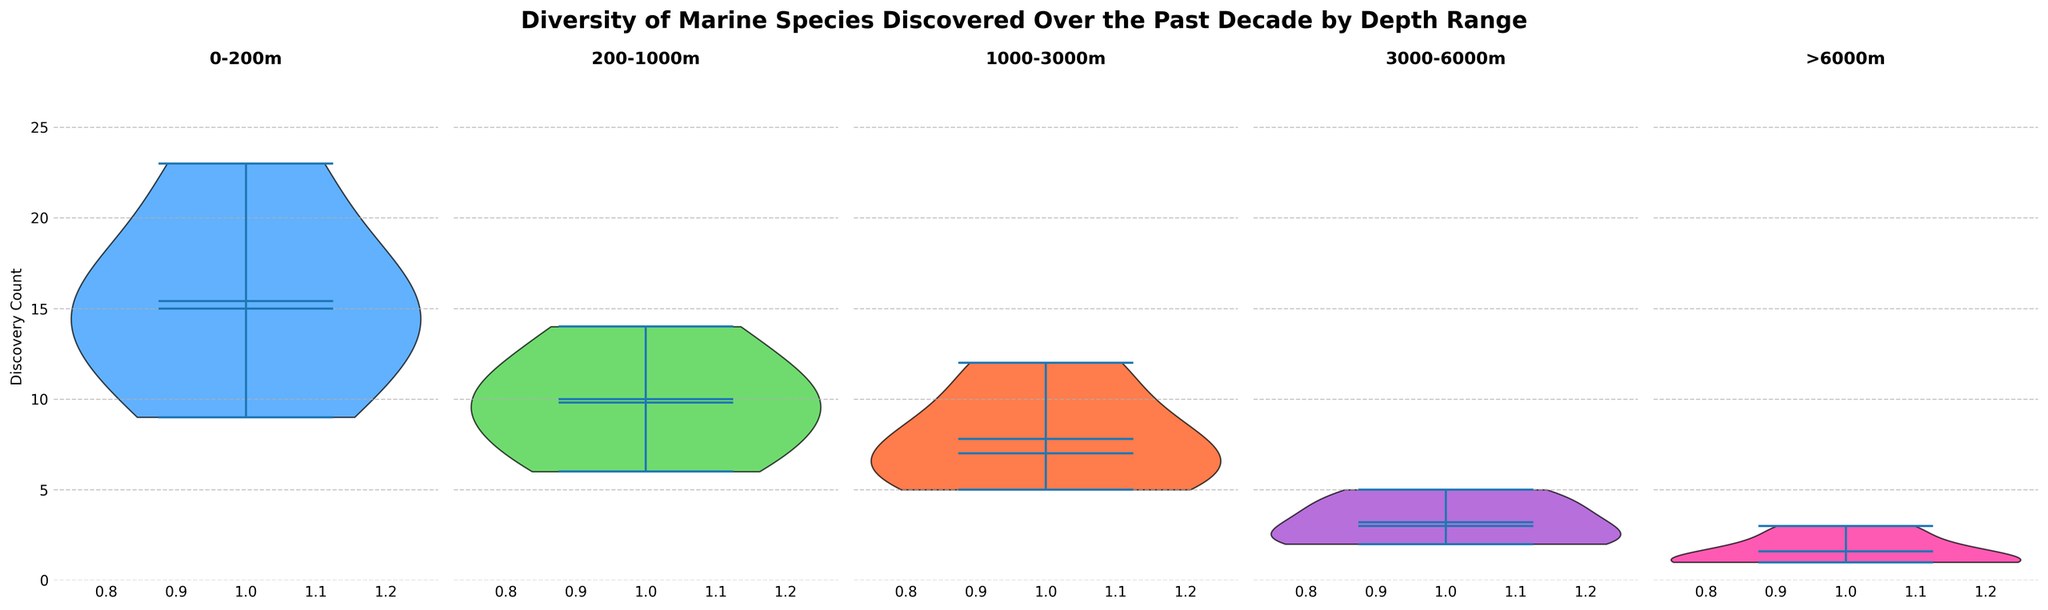What's the title of the figure? The title is displayed at the top of the figure.
Answer: Diversity of Marine Species Discovered Over the Past Decade by Depth Range How many depth ranges are shown in the figure? Each subplot represents a depth range. Counting the subplots provides the answer.
Answer: 5 Which depth range has the highest median discovery count? In each violin plot, the median is indicated by a horizontal line. The tallest median line corresponds to the highest median.
Answer: 0-200m What is the discovery count range for the depth range 3000-6000m? The violin plot for 3000-6000m shows the spread from the lowest to the highest discovery count.
Answer: 2 to 5 How does the distribution of discoveries in the depth range 1000-3000m compare to 200-1000m? The spread, medians, and overall shape of the violin plots indicate the distribution. 1000-3000m has a wider distribution with a higher range of values.
Answer: Wider distribution for 1000-3000m What color represents the species discovered in the depth range 0-200m? Each depth range's violin plot is a different color. The 0-200m plot's color is noted.
Answer: Blue How does the mean discovery count for >6000m compare to the other depth ranges? The mean is shown by the white dot. Comparing its position across depth ranges shows that the mean for >6000m is among the lowest.
Answer: Lower than other ranges What is the most common discovery count for the depth range 0-200m? The widest section of the violin plot corresponds to the most common counts.
Answer: 23 Which depth range has the smallest interquartile range of discovery counts? The interquartile range is indicated by the plots' central bulkiness. The depth range with the smallest interquartile range is the narrowest.
Answer: >6000m Are there any depth ranges where species discoveries have the same maximum discovery count? By inspecting each violin plot's top extremities, 0-200m and 200-1000m share the same maximum discovery count of 23 species.
Answer: Yes 